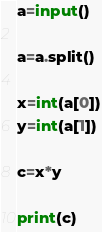<code> <loc_0><loc_0><loc_500><loc_500><_Python_>a=input()

a=a.split()

x=int(a[0])
y=int(a[1])

c=x*y

print(c)</code> 